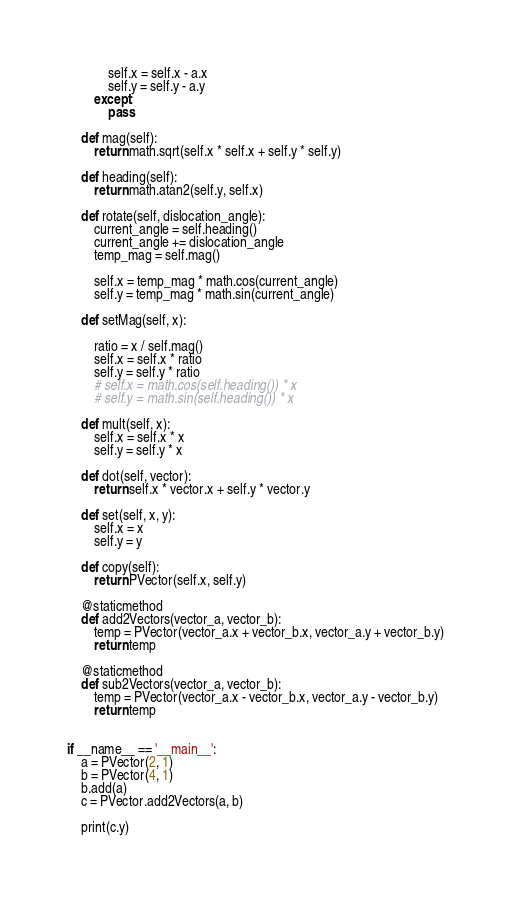Convert code to text. <code><loc_0><loc_0><loc_500><loc_500><_Python_>            self.x = self.x - a.x
            self.y = self.y - a.y
        except:
            pass

    def mag(self):
        return math.sqrt(self.x * self.x + self.y * self.y)

    def heading(self):
        return math.atan2(self.y, self.x)

    def rotate(self, dislocation_angle):
        current_angle = self.heading()
        current_angle += dislocation_angle
        temp_mag = self.mag()

        self.x = temp_mag * math.cos(current_angle)
        self.y = temp_mag * math.sin(current_angle)

    def setMag(self, x):

        ratio = x / self.mag()
        self.x = self.x * ratio
        self.y = self.y * ratio
        # self.x = math.cos(self.heading()) * x
        # self.y = math.sin(self.heading()) * x

    def mult(self, x):
        self.x = self.x * x
        self.y = self.y * x

    def dot(self, vector):
        return self.x * vector.x + self.y * vector.y

    def set(self, x, y):
        self.x = x
        self.y = y

    def copy(self):
        return PVector(self.x, self.y)

    @staticmethod
    def add2Vectors(vector_a, vector_b):
        temp = PVector(vector_a.x + vector_b.x, vector_a.y + vector_b.y)
        return temp

    @staticmethod
    def sub2Vectors(vector_a, vector_b):
        temp = PVector(vector_a.x - vector_b.x, vector_a.y - vector_b.y)
        return temp


if __name__ == '__main__':
    a = PVector(2, 1)
    b = PVector(4, 1)
    b.add(a)
    c = PVector.add2Vectors(a, b)

    print(c.y)
</code> 